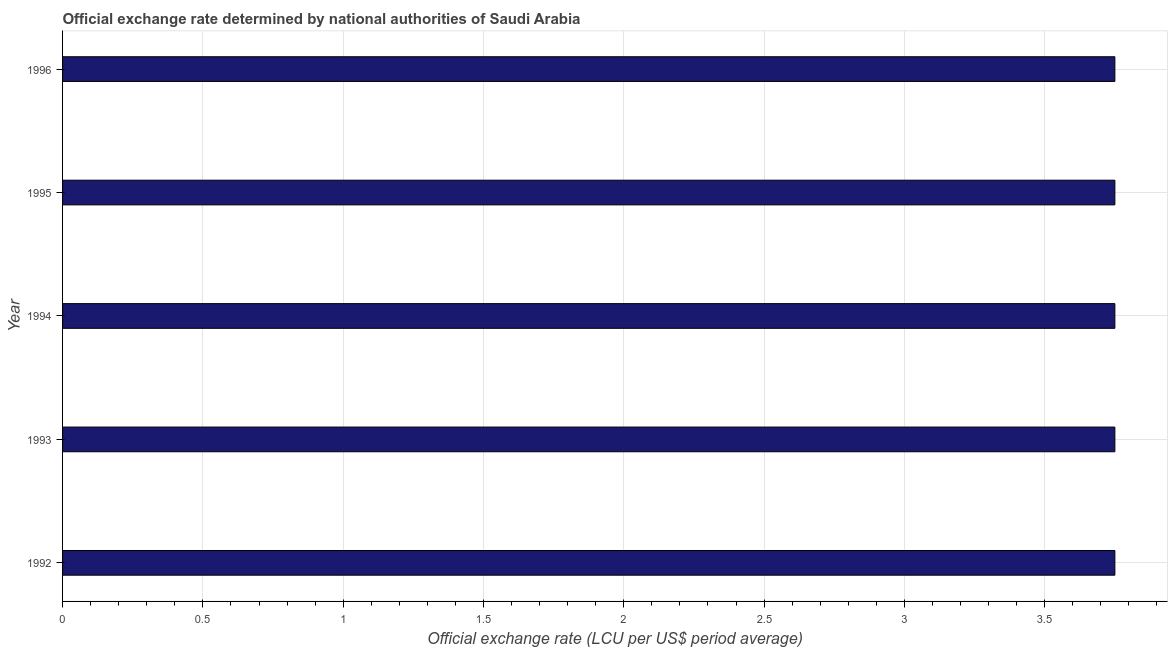Does the graph contain grids?
Give a very brief answer. Yes. What is the title of the graph?
Make the answer very short. Official exchange rate determined by national authorities of Saudi Arabia. What is the label or title of the X-axis?
Your answer should be very brief. Official exchange rate (LCU per US$ period average). What is the label or title of the Y-axis?
Offer a terse response. Year. What is the official exchange rate in 1992?
Make the answer very short. 3.75. Across all years, what is the maximum official exchange rate?
Make the answer very short. 3.75. Across all years, what is the minimum official exchange rate?
Ensure brevity in your answer.  3.75. In which year was the official exchange rate maximum?
Provide a succinct answer. 1992. In which year was the official exchange rate minimum?
Offer a very short reply. 1992. What is the sum of the official exchange rate?
Your response must be concise. 18.75. What is the average official exchange rate per year?
Provide a short and direct response. 3.75. What is the median official exchange rate?
Give a very brief answer. 3.75. Do a majority of the years between 1993 and 1996 (inclusive) have official exchange rate greater than 2.3 ?
Your answer should be compact. Yes. What is the ratio of the official exchange rate in 1995 to that in 1996?
Make the answer very short. 1. Is the difference between the official exchange rate in 1993 and 1996 greater than the difference between any two years?
Your answer should be compact. Yes. Is the sum of the official exchange rate in 1992 and 1993 greater than the maximum official exchange rate across all years?
Keep it short and to the point. Yes. What is the difference between the highest and the lowest official exchange rate?
Offer a very short reply. 0. Are all the bars in the graph horizontal?
Your answer should be very brief. Yes. Are the values on the major ticks of X-axis written in scientific E-notation?
Provide a short and direct response. No. What is the Official exchange rate (LCU per US$ period average) in 1992?
Your response must be concise. 3.75. What is the Official exchange rate (LCU per US$ period average) of 1993?
Your response must be concise. 3.75. What is the Official exchange rate (LCU per US$ period average) of 1994?
Your answer should be compact. 3.75. What is the Official exchange rate (LCU per US$ period average) in 1995?
Your response must be concise. 3.75. What is the Official exchange rate (LCU per US$ period average) of 1996?
Make the answer very short. 3.75. What is the difference between the Official exchange rate (LCU per US$ period average) in 1992 and 1993?
Your answer should be very brief. 0. What is the difference between the Official exchange rate (LCU per US$ period average) in 1992 and 1994?
Keep it short and to the point. 0. What is the difference between the Official exchange rate (LCU per US$ period average) in 1992 and 1995?
Make the answer very short. 0. What is the difference between the Official exchange rate (LCU per US$ period average) in 1994 and 1995?
Provide a short and direct response. 0. What is the difference between the Official exchange rate (LCU per US$ period average) in 1995 and 1996?
Your response must be concise. 0. What is the ratio of the Official exchange rate (LCU per US$ period average) in 1992 to that in 1995?
Offer a terse response. 1. What is the ratio of the Official exchange rate (LCU per US$ period average) in 1992 to that in 1996?
Provide a succinct answer. 1. What is the ratio of the Official exchange rate (LCU per US$ period average) in 1993 to that in 1996?
Make the answer very short. 1. What is the ratio of the Official exchange rate (LCU per US$ period average) in 1994 to that in 1996?
Provide a succinct answer. 1. 